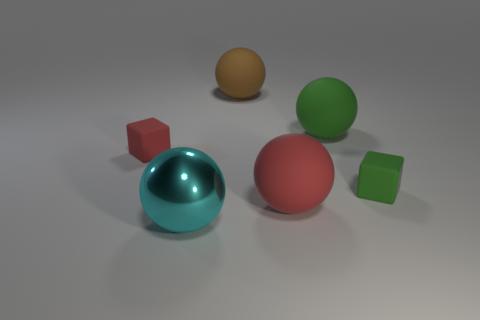Subtract all cyan spheres. How many spheres are left? 3 Subtract 2 balls. How many balls are left? 2 Add 1 large green cylinders. How many objects exist? 7 Subtract all yellow spheres. Subtract all yellow cylinders. How many spheres are left? 4 Subtract all spheres. How many objects are left? 2 Subtract all red cylinders. Subtract all large green rubber things. How many objects are left? 5 Add 3 large shiny objects. How many large shiny objects are left? 4 Add 1 large matte balls. How many large matte balls exist? 4 Subtract 0 purple cylinders. How many objects are left? 6 